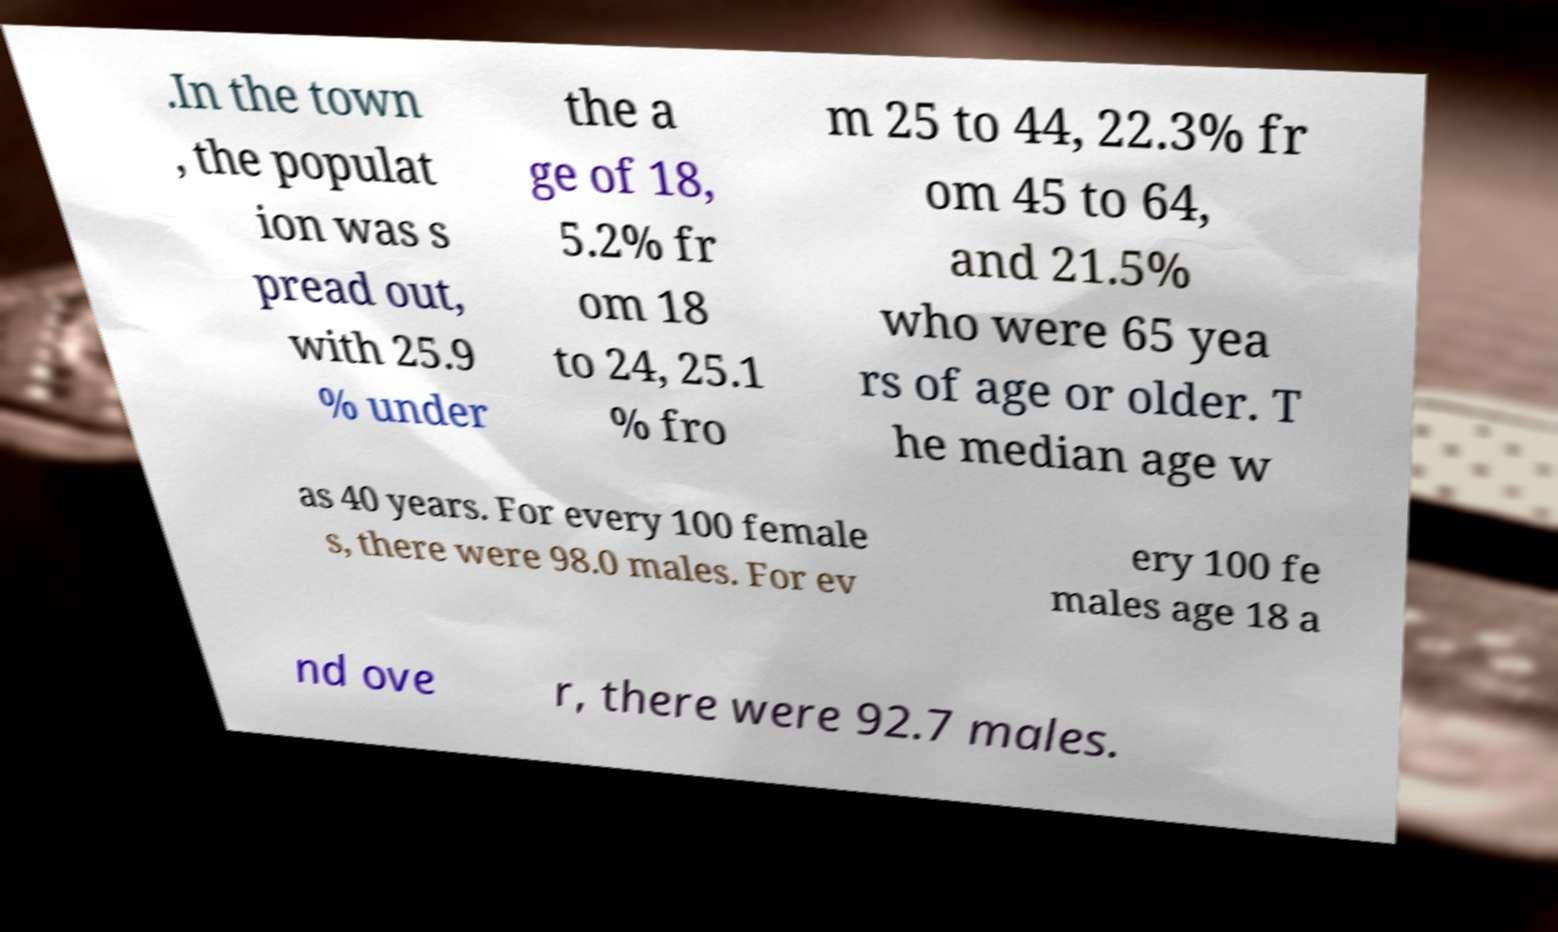What messages or text are displayed in this image? I need them in a readable, typed format. .In the town , the populat ion was s pread out, with 25.9 % under the a ge of 18, 5.2% fr om 18 to 24, 25.1 % fro m 25 to 44, 22.3% fr om 45 to 64, and 21.5% who were 65 yea rs of age or older. T he median age w as 40 years. For every 100 female s, there were 98.0 males. For ev ery 100 fe males age 18 a nd ove r, there were 92.7 males. 